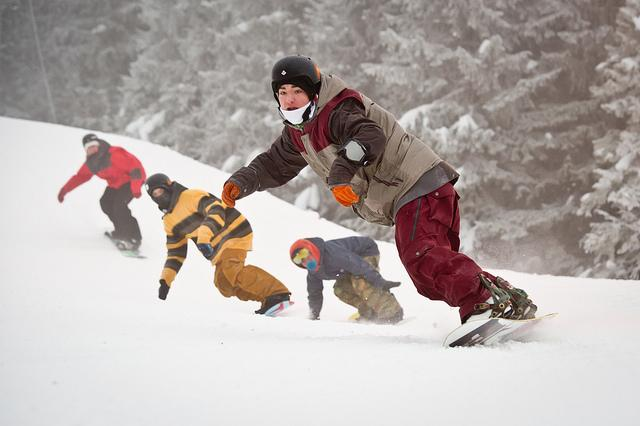Why are the men leaning to one side? Please explain your reasoning. to turn. The men are changing direction. 